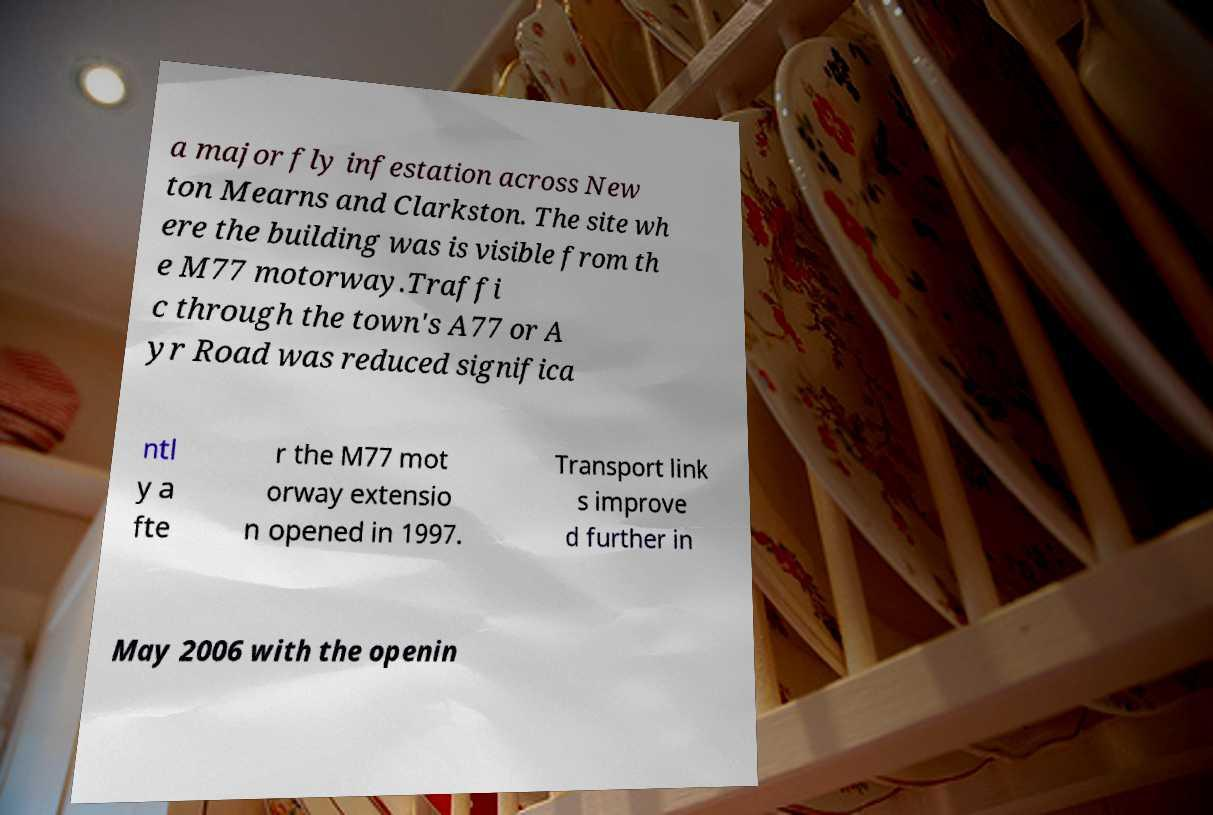There's text embedded in this image that I need extracted. Can you transcribe it verbatim? a major fly infestation across New ton Mearns and Clarkston. The site wh ere the building was is visible from th e M77 motorway.Traffi c through the town's A77 or A yr Road was reduced significa ntl y a fte r the M77 mot orway extensio n opened in 1997. Transport link s improve d further in May 2006 with the openin 